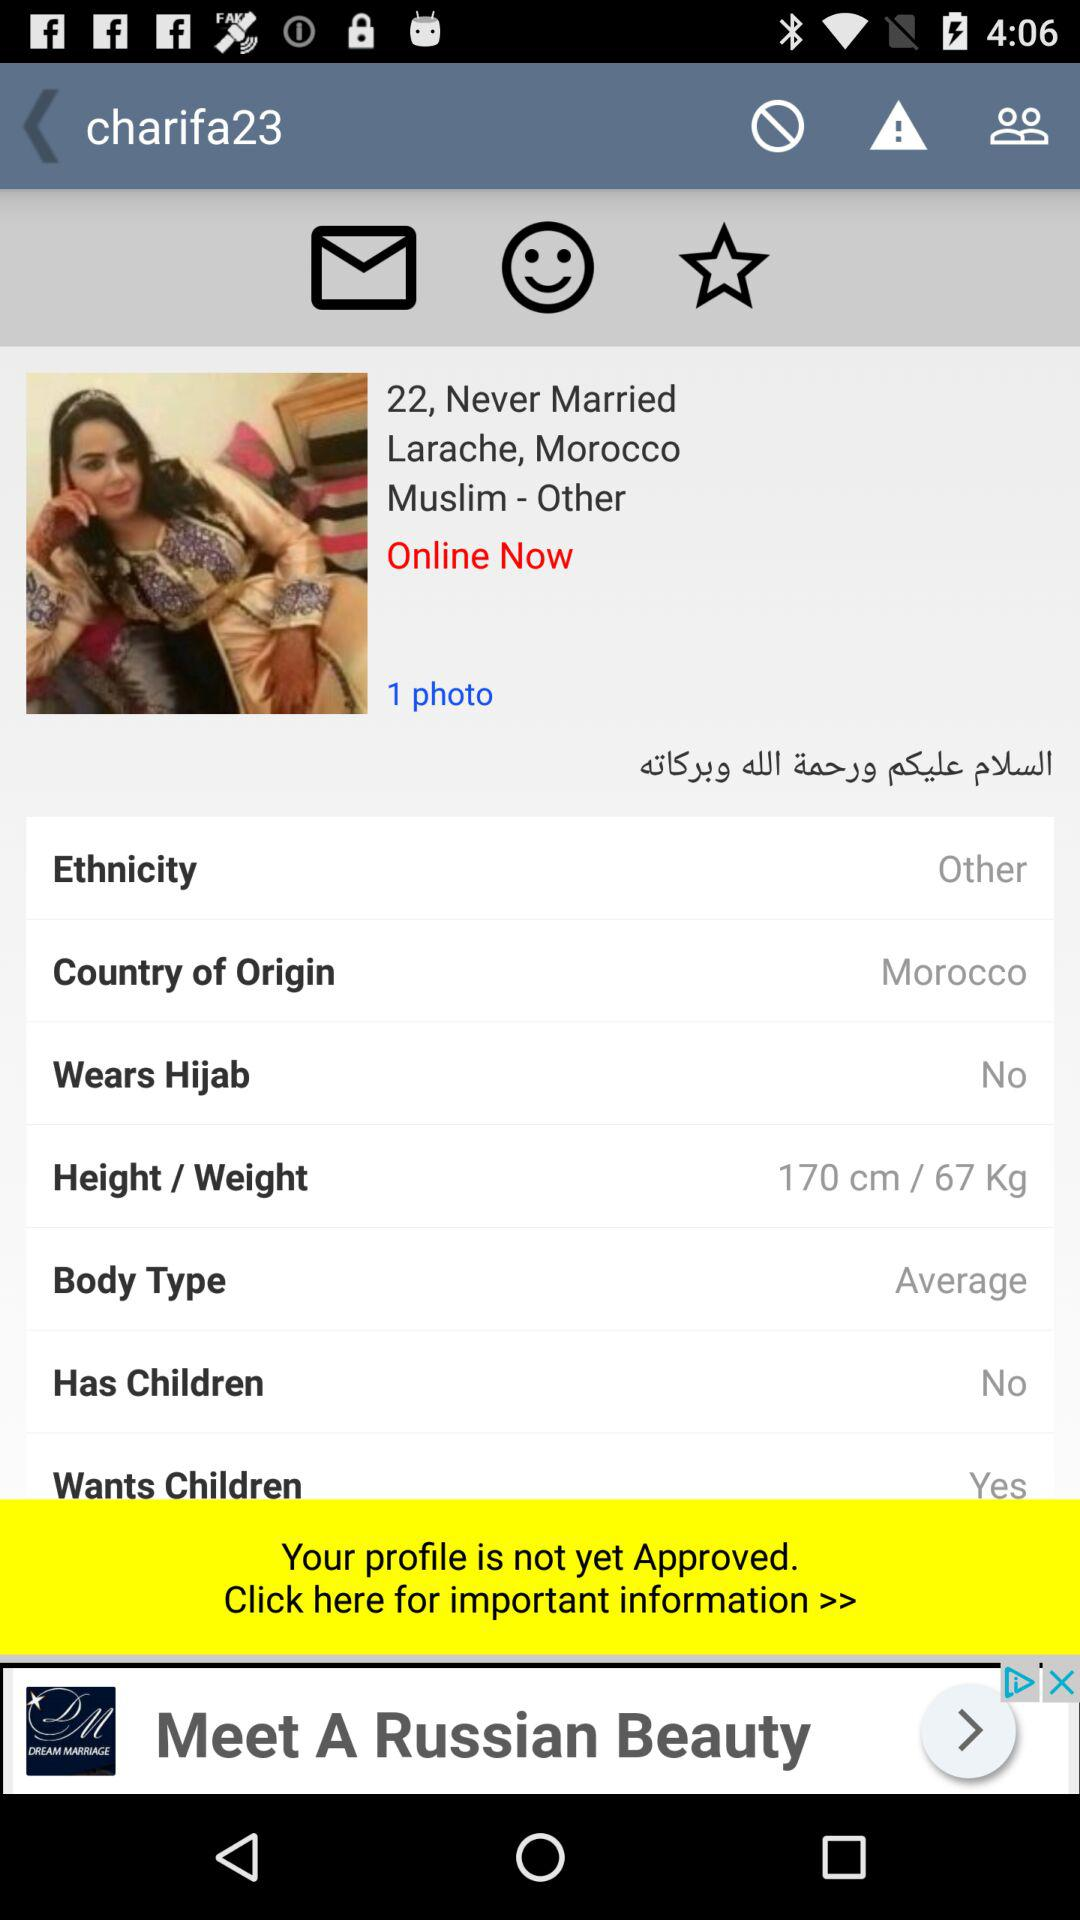What is the body type? The body type is average. 